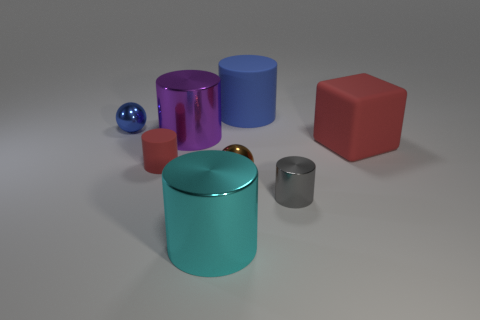What number of objects are either shiny cylinders that are in front of the tiny red matte cylinder or big red matte objects?
Your answer should be compact. 3. There is a thing that is left of the rubber object in front of the big red cube; what shape is it?
Give a very brief answer. Sphere. There is a blue metallic thing; is it the same size as the ball right of the purple thing?
Provide a succinct answer. Yes. What is the small sphere behind the big red matte block made of?
Your response must be concise. Metal. How many shiny cylinders are in front of the tiny rubber cylinder and behind the large cyan cylinder?
Your answer should be very brief. 1. There is a cube that is the same size as the cyan object; what material is it?
Give a very brief answer. Rubber. There is a shiny thing that is behind the large purple cylinder; does it have the same size as the red rubber object to the left of the cyan metallic object?
Keep it short and to the point. Yes. Are there any shiny cylinders behind the gray metallic object?
Give a very brief answer. Yes. The metallic cylinder right of the sphere in front of the small blue metal ball is what color?
Provide a succinct answer. Gray. Is the number of gray cylinders less than the number of green metal cylinders?
Offer a very short reply. No. 